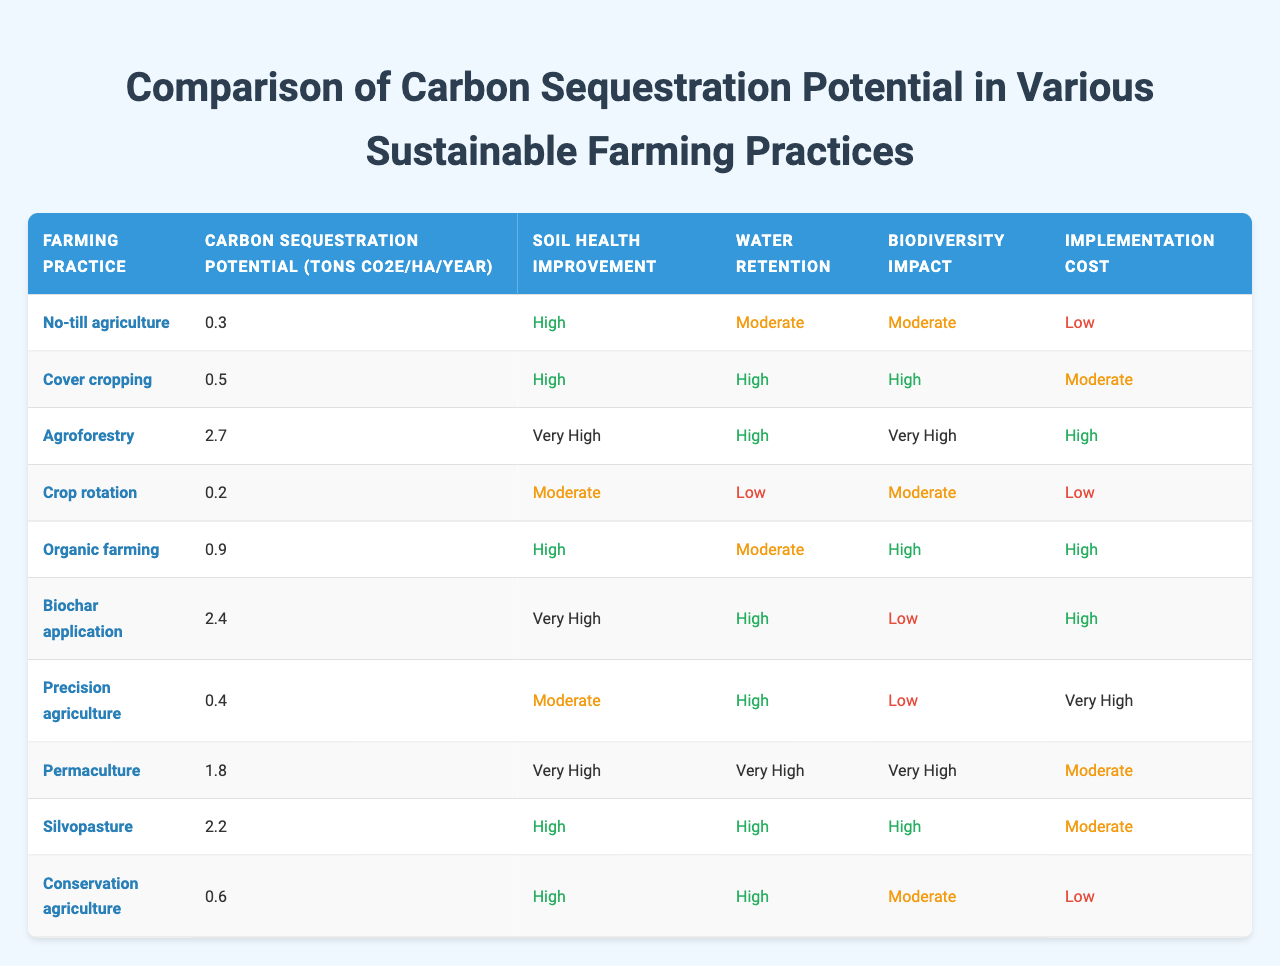What is the carbon sequestration potential of agroforestry? The table lists agroforestry's carbon sequestration potential as 2.7 tons CO2e/ha/year.
Answer: 2.7 tons CO2e/ha/year Which farming practice has the highest soil health improvement rating? Agroforestry, biochar application, and permaculture have a "Very High" rating for soil health improvement.
Answer: Agroforestry, biochar application, and permaculture How much more carbon can be sequestered by agroforestry compared to crop rotation? Agroforestry sequesters 2.7 tons CO2e/ha/year while crop rotation sequesters 0.2 tons CO2e/ha/year. The difference is 2.7 - 0.2 = 2.5 tons CO2e/ha/year.
Answer: 2.5 tons CO2e/ha/year Is the implementation cost of precision agriculture higher than that of cover cropping? Precision agriculture has a "Very High" implementation cost while cover cropping has a "Moderate" cost, which means precision agriculture is indeed higher.
Answer: Yes What is the average carbon sequestration potential of all the farming practices listed in the table? The carbon sequestration values are: 0.3, 0.5, 2.7, 0.2, 0.9, 2.4, 0.4, 1.8, 2.2, and 0.6. Summing these gives 9.1 tons CO2e, and dividing by 10 (the number of practices) gives an average of 0.91 tons CO2e/ha/year.
Answer: 0.91 tons CO2e/ha/year Which farming practices show high or very high ratings for biodiversity impact? Cover cropping, agroforestry, organic farming, permaculture, and silvopasture all have high or very high ratings for biodiversity impact.
Answer: Cover cropping, agroforestry, organic farming, permaculture, and silvopasture What is the relationship between soil health improvement and carbon sequestration potential for organic farming? Organic farming has a high soil health improvement rating and a carbon sequestration potential of 0.9 tons CO2e/ha/year. This suggests that it effectively improves soil health while sequestering carbon.
Answer: High improvement with 0.9 tons CO2e/ha/year Which farming practice is notably effective regarding both carbon sequestration and soil health? Agroforestry is particularly effective, with a high carbon sequestration potential of 2.7 tons CO2e/ha/year and a very high rating for soil health improvement.
Answer: Agroforestry Is it true that conservation agriculture has the lowest carbon sequestration potential among all practices? No, conservation agriculture has a carbon sequestration potential of 0.6 tons CO2e/ha/year, which is higher than crop rotation at 0.2 tons CO2e/ha/year.
Answer: No Which practice offers the best balance of carbon sequestration potential and water retention? Agroforestry has the highest carbon sequestration potential (2.7 tons CO2e/ha/year) and high water retention. This shows a strong balance in both metrics.
Answer: Agroforestry 